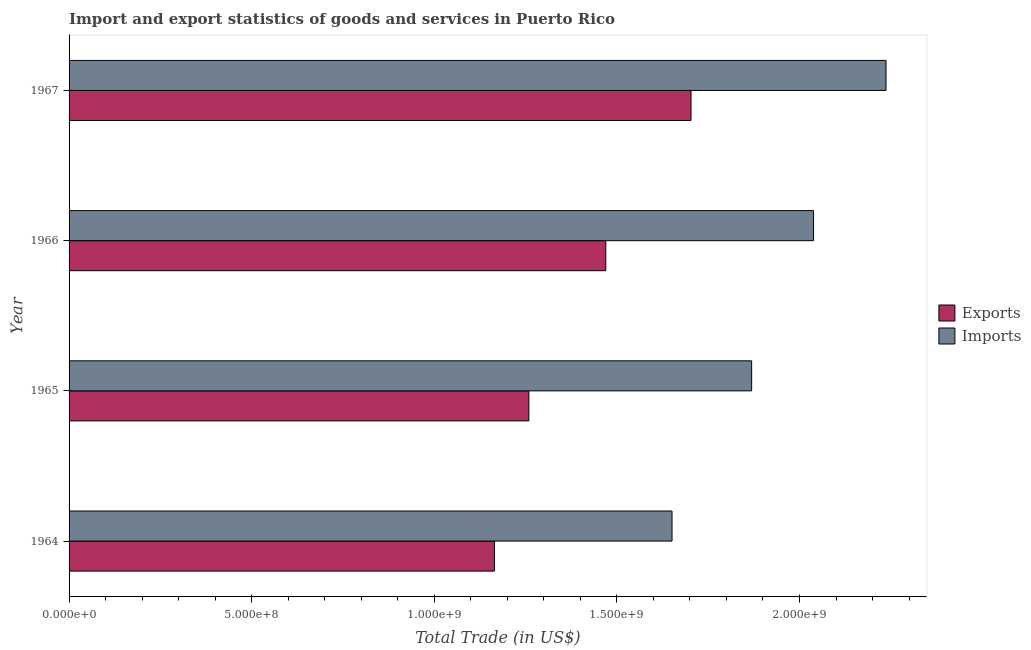Are the number of bars per tick equal to the number of legend labels?
Give a very brief answer. Yes. How many bars are there on the 3rd tick from the top?
Give a very brief answer. 2. How many bars are there on the 4th tick from the bottom?
Your response must be concise. 2. What is the label of the 4th group of bars from the top?
Your response must be concise. 1964. What is the imports of goods and services in 1965?
Provide a short and direct response. 1.87e+09. Across all years, what is the maximum imports of goods and services?
Your response must be concise. 2.24e+09. Across all years, what is the minimum imports of goods and services?
Provide a short and direct response. 1.65e+09. In which year was the imports of goods and services maximum?
Provide a succinct answer. 1967. In which year was the export of goods and services minimum?
Offer a terse response. 1964. What is the total imports of goods and services in the graph?
Make the answer very short. 7.80e+09. What is the difference between the imports of goods and services in 1966 and that in 1967?
Offer a very short reply. -1.98e+08. What is the difference between the imports of goods and services in 1967 and the export of goods and services in 1964?
Give a very brief answer. 1.07e+09. What is the average export of goods and services per year?
Offer a terse response. 1.40e+09. In the year 1965, what is the difference between the export of goods and services and imports of goods and services?
Provide a short and direct response. -6.10e+08. What is the ratio of the imports of goods and services in 1964 to that in 1967?
Give a very brief answer. 0.74. Is the export of goods and services in 1964 less than that in 1965?
Provide a short and direct response. Yes. What is the difference between the highest and the second highest export of goods and services?
Provide a short and direct response. 2.33e+08. What is the difference between the highest and the lowest imports of goods and services?
Offer a very short reply. 5.86e+08. In how many years, is the export of goods and services greater than the average export of goods and services taken over all years?
Keep it short and to the point. 2. What does the 2nd bar from the top in 1966 represents?
Give a very brief answer. Exports. What does the 1st bar from the bottom in 1967 represents?
Make the answer very short. Exports. Are the values on the major ticks of X-axis written in scientific E-notation?
Provide a short and direct response. Yes. Does the graph contain grids?
Make the answer very short. No. Where does the legend appear in the graph?
Give a very brief answer. Center right. How are the legend labels stacked?
Provide a succinct answer. Vertical. What is the title of the graph?
Keep it short and to the point. Import and export statistics of goods and services in Puerto Rico. What is the label or title of the X-axis?
Your answer should be compact. Total Trade (in US$). What is the label or title of the Y-axis?
Keep it short and to the point. Year. What is the Total Trade (in US$) of Exports in 1964?
Keep it short and to the point. 1.16e+09. What is the Total Trade (in US$) in Imports in 1964?
Offer a terse response. 1.65e+09. What is the Total Trade (in US$) in Exports in 1965?
Your answer should be compact. 1.26e+09. What is the Total Trade (in US$) in Imports in 1965?
Provide a short and direct response. 1.87e+09. What is the Total Trade (in US$) of Exports in 1966?
Provide a succinct answer. 1.47e+09. What is the Total Trade (in US$) of Imports in 1966?
Give a very brief answer. 2.04e+09. What is the Total Trade (in US$) of Exports in 1967?
Your answer should be very brief. 1.70e+09. What is the Total Trade (in US$) of Imports in 1967?
Provide a succinct answer. 2.24e+09. Across all years, what is the maximum Total Trade (in US$) in Exports?
Your answer should be very brief. 1.70e+09. Across all years, what is the maximum Total Trade (in US$) in Imports?
Ensure brevity in your answer.  2.24e+09. Across all years, what is the minimum Total Trade (in US$) in Exports?
Your response must be concise. 1.16e+09. Across all years, what is the minimum Total Trade (in US$) in Imports?
Provide a succinct answer. 1.65e+09. What is the total Total Trade (in US$) in Exports in the graph?
Make the answer very short. 5.60e+09. What is the total Total Trade (in US$) in Imports in the graph?
Your answer should be very brief. 7.80e+09. What is the difference between the Total Trade (in US$) of Exports in 1964 and that in 1965?
Provide a short and direct response. -9.43e+07. What is the difference between the Total Trade (in US$) in Imports in 1964 and that in 1965?
Your response must be concise. -2.18e+08. What is the difference between the Total Trade (in US$) of Exports in 1964 and that in 1966?
Give a very brief answer. -3.05e+08. What is the difference between the Total Trade (in US$) in Imports in 1964 and that in 1966?
Your response must be concise. -3.87e+08. What is the difference between the Total Trade (in US$) of Exports in 1964 and that in 1967?
Your answer should be compact. -5.38e+08. What is the difference between the Total Trade (in US$) in Imports in 1964 and that in 1967?
Offer a terse response. -5.86e+08. What is the difference between the Total Trade (in US$) of Exports in 1965 and that in 1966?
Your answer should be compact. -2.11e+08. What is the difference between the Total Trade (in US$) in Imports in 1965 and that in 1966?
Give a very brief answer. -1.70e+08. What is the difference between the Total Trade (in US$) in Exports in 1965 and that in 1967?
Make the answer very short. -4.44e+08. What is the difference between the Total Trade (in US$) of Imports in 1965 and that in 1967?
Ensure brevity in your answer.  -3.68e+08. What is the difference between the Total Trade (in US$) of Exports in 1966 and that in 1967?
Give a very brief answer. -2.33e+08. What is the difference between the Total Trade (in US$) of Imports in 1966 and that in 1967?
Offer a very short reply. -1.98e+08. What is the difference between the Total Trade (in US$) of Exports in 1964 and the Total Trade (in US$) of Imports in 1965?
Ensure brevity in your answer.  -7.04e+08. What is the difference between the Total Trade (in US$) of Exports in 1964 and the Total Trade (in US$) of Imports in 1966?
Your answer should be compact. -8.74e+08. What is the difference between the Total Trade (in US$) of Exports in 1964 and the Total Trade (in US$) of Imports in 1967?
Keep it short and to the point. -1.07e+09. What is the difference between the Total Trade (in US$) of Exports in 1965 and the Total Trade (in US$) of Imports in 1966?
Your response must be concise. -7.79e+08. What is the difference between the Total Trade (in US$) of Exports in 1965 and the Total Trade (in US$) of Imports in 1967?
Provide a short and direct response. -9.78e+08. What is the difference between the Total Trade (in US$) of Exports in 1966 and the Total Trade (in US$) of Imports in 1967?
Offer a very short reply. -7.67e+08. What is the average Total Trade (in US$) of Exports per year?
Give a very brief answer. 1.40e+09. What is the average Total Trade (in US$) of Imports per year?
Keep it short and to the point. 1.95e+09. In the year 1964, what is the difference between the Total Trade (in US$) in Exports and Total Trade (in US$) in Imports?
Keep it short and to the point. -4.86e+08. In the year 1965, what is the difference between the Total Trade (in US$) in Exports and Total Trade (in US$) in Imports?
Your answer should be compact. -6.10e+08. In the year 1966, what is the difference between the Total Trade (in US$) of Exports and Total Trade (in US$) of Imports?
Your response must be concise. -5.69e+08. In the year 1967, what is the difference between the Total Trade (in US$) of Exports and Total Trade (in US$) of Imports?
Keep it short and to the point. -5.34e+08. What is the ratio of the Total Trade (in US$) in Exports in 1964 to that in 1965?
Make the answer very short. 0.93. What is the ratio of the Total Trade (in US$) in Imports in 1964 to that in 1965?
Give a very brief answer. 0.88. What is the ratio of the Total Trade (in US$) of Exports in 1964 to that in 1966?
Your answer should be very brief. 0.79. What is the ratio of the Total Trade (in US$) in Imports in 1964 to that in 1966?
Offer a terse response. 0.81. What is the ratio of the Total Trade (in US$) of Exports in 1964 to that in 1967?
Keep it short and to the point. 0.68. What is the ratio of the Total Trade (in US$) in Imports in 1964 to that in 1967?
Make the answer very short. 0.74. What is the ratio of the Total Trade (in US$) in Exports in 1965 to that in 1966?
Offer a very short reply. 0.86. What is the ratio of the Total Trade (in US$) in Imports in 1965 to that in 1966?
Offer a very short reply. 0.92. What is the ratio of the Total Trade (in US$) of Exports in 1965 to that in 1967?
Offer a terse response. 0.74. What is the ratio of the Total Trade (in US$) in Imports in 1965 to that in 1967?
Your answer should be very brief. 0.84. What is the ratio of the Total Trade (in US$) in Exports in 1966 to that in 1967?
Provide a succinct answer. 0.86. What is the ratio of the Total Trade (in US$) in Imports in 1966 to that in 1967?
Offer a terse response. 0.91. What is the difference between the highest and the second highest Total Trade (in US$) of Exports?
Make the answer very short. 2.33e+08. What is the difference between the highest and the second highest Total Trade (in US$) in Imports?
Give a very brief answer. 1.98e+08. What is the difference between the highest and the lowest Total Trade (in US$) in Exports?
Keep it short and to the point. 5.38e+08. What is the difference between the highest and the lowest Total Trade (in US$) in Imports?
Make the answer very short. 5.86e+08. 